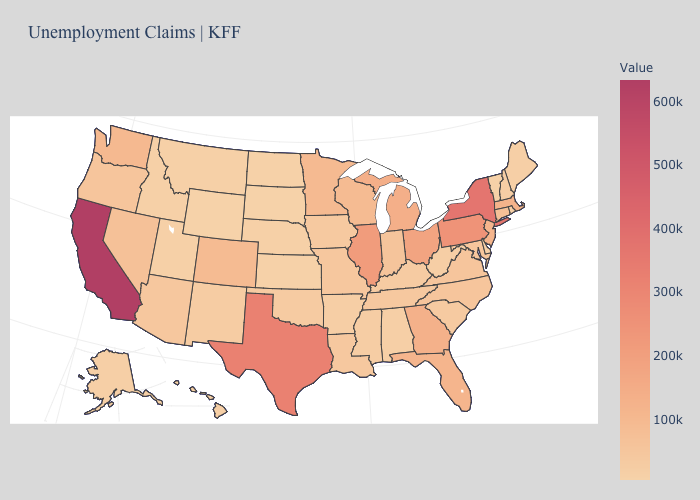Which states have the lowest value in the USA?
Keep it brief. Wyoming. Among the states that border Minnesota , does Wisconsin have the highest value?
Short answer required. Yes. Which states have the highest value in the USA?
Write a very short answer. California. Which states have the lowest value in the USA?
Be succinct. Wyoming. Which states have the lowest value in the USA?
Keep it brief. Wyoming. Does Maine have a lower value than Michigan?
Give a very brief answer. Yes. 